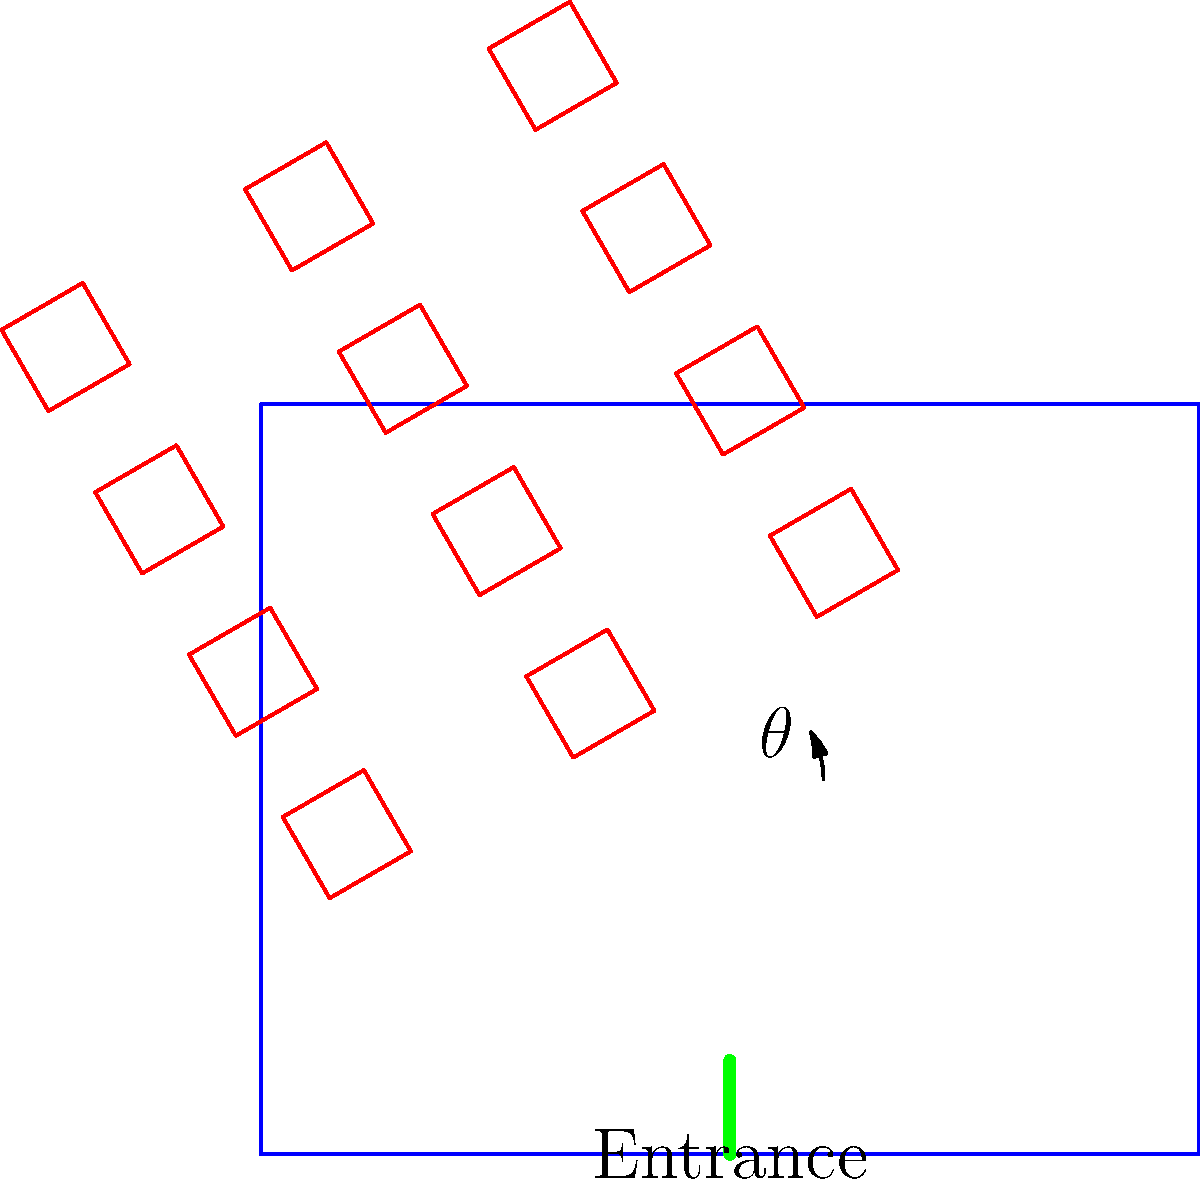In a casino layout, slot machines are positioned at an angle $\theta$ from the main walkway to maximize player engagement and foot traffic flow. Given that the optimal viewing angle for a slot machine is 45°, and considering a 15° buffer for comfortable player positioning, what is the ideal angle $\theta$ for arranging the slot machines relative to the main walkway? To determine the ideal angle for positioning slot machines, we need to consider several factors:

1. Optimal viewing angle: 45°
2. Buffer for comfortable player positioning: 15°
3. Desired angle relative to the main walkway: $\theta$

Step 1: Calculate the total angle needed for optimal viewing and player comfort.
Total angle = Optimal viewing angle + Buffer
Total angle = 45° + 15° = 60°

Step 2: Determine the relationship between the total angle and $\theta$.
The total angle (60°) should be perpendicular to the slot machine's face for optimal engagement. This means that $\theta$ and the total angle should form a right angle (90°).

Step 3: Calculate $\theta$ using the right angle relationship.
$\theta + 60° = 90°$
$\theta = 90° - 60°$
$\theta = 30°$

Therefore, the ideal angle for positioning slot machines relative to the main walkway is 30°. This arrangement allows for optimal viewing, comfortable player positioning, and efficient foot traffic flow.
Answer: $30°$ 